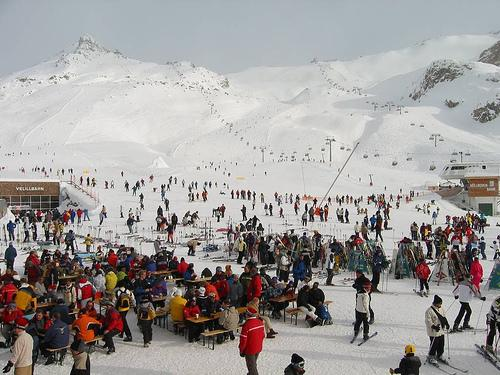What is on the floor? snow 